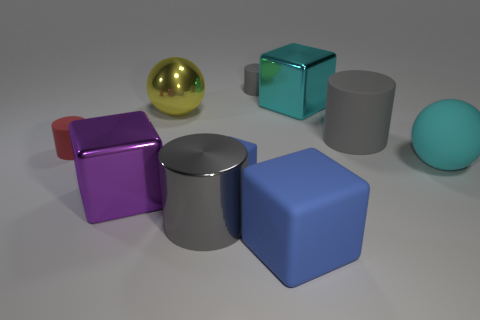How do the objects' shapes and colors play with the concept of diversity? The variety of shapes—cubes, a cylinder, and spheres—and the range of colors from vibrant purple and teal to subdued gray and blue, illustrate diversity through visual means. It conveys the idea that despite differences in appearance and characteristics, all elements have their place and contribute to the composition's overall harmony and balance. 